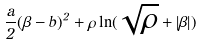Convert formula to latex. <formula><loc_0><loc_0><loc_500><loc_500>\frac { a } { 2 } ( \beta - b ) ^ { 2 } + \rho \ln ( \sqrt { \rho } + | \beta | )</formula> 